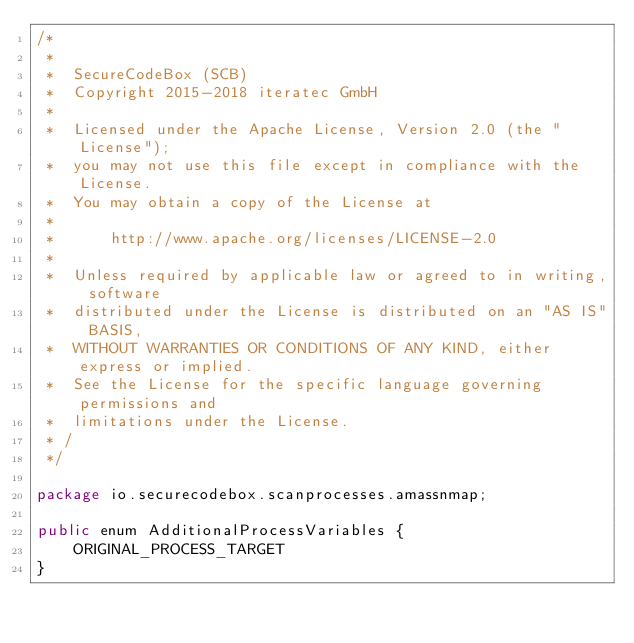<code> <loc_0><loc_0><loc_500><loc_500><_Java_>/*
 *
 *  SecureCodeBox (SCB)
 *  Copyright 2015-2018 iteratec GmbH
 *
 *  Licensed under the Apache License, Version 2.0 (the "License");
 *  you may not use this file except in compliance with the License.
 *  You may obtain a copy of the License at
 *
 *  	http://www.apache.org/licenses/LICENSE-2.0
 *
 *  Unless required by applicable law or agreed to in writing, software
 *  distributed under the License is distributed on an "AS IS" BASIS,
 *  WITHOUT WARRANTIES OR CONDITIONS OF ANY KIND, either express or implied.
 *  See the License for the specific language governing permissions and
 *  limitations under the License.
 * /
 */

package io.securecodebox.scanprocesses.amassnmap;

public enum AdditionalProcessVariables {
    ORIGINAL_PROCESS_TARGET
}
</code> 